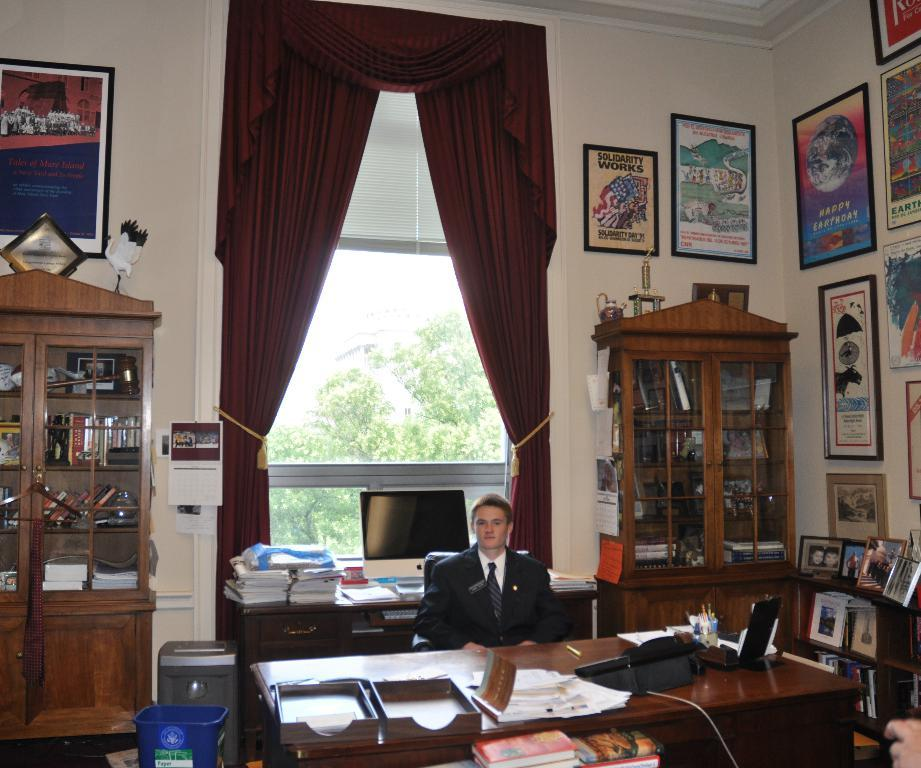<image>
Render a clear and concise summary of the photo. A framed poster high on an office wall proclaims that Solidarity Works. 